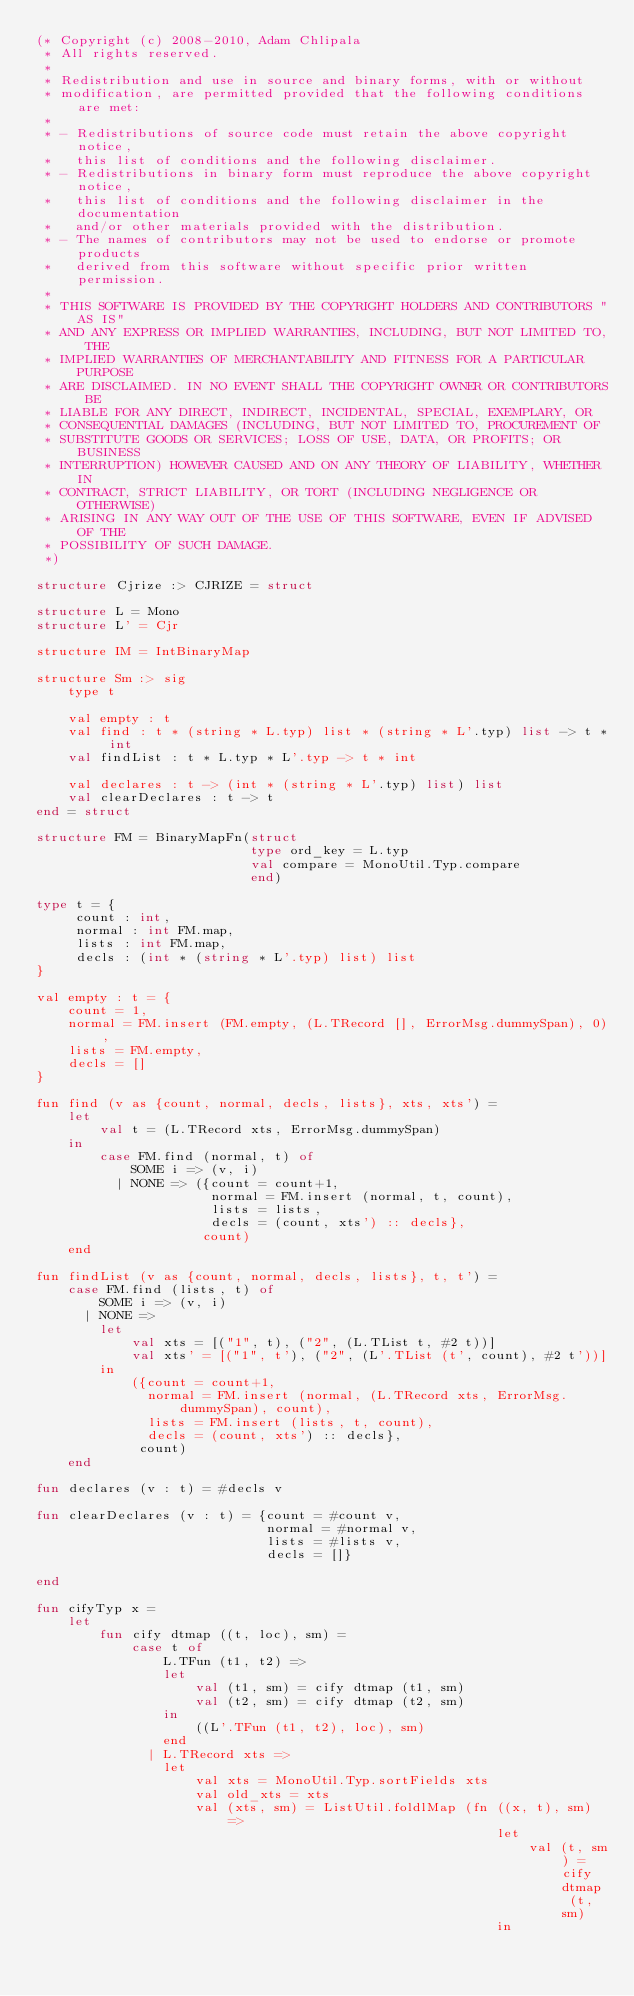<code> <loc_0><loc_0><loc_500><loc_500><_SML_>(* Copyright (c) 2008-2010, Adam Chlipala
 * All rights reserved.
 *
 * Redistribution and use in source and binary forms, with or without
 * modification, are permitted provided that the following conditions are met:
 *
 * - Redistributions of source code must retain the above copyright notice,
 *   this list of conditions and the following disclaimer.
 * - Redistributions in binary form must reproduce the above copyright notice,
 *   this list of conditions and the following disclaimer in the documentation
 *   and/or other materials provided with the distribution.
 * - The names of contributors may not be used to endorse or promote products
 *   derived from this software without specific prior written permission.
 *
 * THIS SOFTWARE IS PROVIDED BY THE COPYRIGHT HOLDERS AND CONTRIBUTORS "AS IS"
 * AND ANY EXPRESS OR IMPLIED WARRANTIES, INCLUDING, BUT NOT LIMITED TO, THE
 * IMPLIED WARRANTIES OF MERCHANTABILITY AND FITNESS FOR A PARTICULAR PURPOSE
 * ARE DISCLAIMED. IN NO EVENT SHALL THE COPYRIGHT OWNER OR CONTRIBUTORS BE
 * LIABLE FOR ANY DIRECT, INDIRECT, INCIDENTAL, SPECIAL, EXEMPLARY, OR
 * CONSEQUENTIAL DAMAGES (INCLUDING, BUT NOT LIMITED TO, PROCUREMENT OF
 * SUBSTITUTE GOODS OR SERVICES; LOSS OF USE, DATA, OR PROFITS; OR BUSINESS
 * INTERRUPTION) HOWEVER CAUSED AND ON ANY THEORY OF LIABILITY, WHETHER IN
 * CONTRACT, STRICT LIABILITY, OR TORT (INCLUDING NEGLIGENCE OR OTHERWISE)
 * ARISING IN ANY WAY OUT OF THE USE OF THIS SOFTWARE, EVEN IF ADVISED OF THE
 * POSSIBILITY OF SUCH DAMAGE.
 *)

structure Cjrize :> CJRIZE = struct

structure L = Mono
structure L' = Cjr

structure IM = IntBinaryMap

structure Sm :> sig
    type t

    val empty : t
    val find : t * (string * L.typ) list * (string * L'.typ) list -> t * int
    val findList : t * L.typ * L'.typ -> t * int

    val declares : t -> (int * (string * L'.typ) list) list
    val clearDeclares : t -> t
end = struct

structure FM = BinaryMapFn(struct
                           type ord_key = L.typ
                           val compare = MonoUtil.Typ.compare
                           end)

type t = {
     count : int,
     normal : int FM.map,
     lists : int FM.map,
     decls : (int * (string * L'.typ) list) list
}

val empty : t = {
    count = 1,
    normal = FM.insert (FM.empty, (L.TRecord [], ErrorMsg.dummySpan), 0),
    lists = FM.empty,
    decls = []
}

fun find (v as {count, normal, decls, lists}, xts, xts') =
    let
        val t = (L.TRecord xts, ErrorMsg.dummySpan)
    in
        case FM.find (normal, t) of
            SOME i => (v, i)
          | NONE => ({count = count+1,
                      normal = FM.insert (normal, t, count),
                      lists = lists,
                      decls = (count, xts') :: decls},
                     count)
    end

fun findList (v as {count, normal, decls, lists}, t, t') =
    case FM.find (lists, t) of
        SOME i => (v, i)
      | NONE =>
        let
            val xts = [("1", t), ("2", (L.TList t, #2 t))]
            val xts' = [("1", t'), ("2", (L'.TList (t', count), #2 t'))]
        in
            ({count = count+1,
              normal = FM.insert (normal, (L.TRecord xts, ErrorMsg.dummySpan), count),
              lists = FM.insert (lists, t, count),
              decls = (count, xts') :: decls},
             count)
    end

fun declares (v : t) = #decls v

fun clearDeclares (v : t) = {count = #count v,
                             normal = #normal v,
                             lists = #lists v,
                             decls = []}

end

fun cifyTyp x =
    let
        fun cify dtmap ((t, loc), sm) =
            case t of
                L.TFun (t1, t2) =>
                let
                    val (t1, sm) = cify dtmap (t1, sm)
                    val (t2, sm) = cify dtmap (t2, sm)
                in
                    ((L'.TFun (t1, t2), loc), sm)
                end
              | L.TRecord xts =>
                let
                    val xts = MonoUtil.Typ.sortFields xts
                    val old_xts = xts
                    val (xts, sm) = ListUtil.foldlMap (fn ((x, t), sm) =>
                                                          let
                                                              val (t, sm) = cify dtmap (t, sm)
                                                          in</code> 